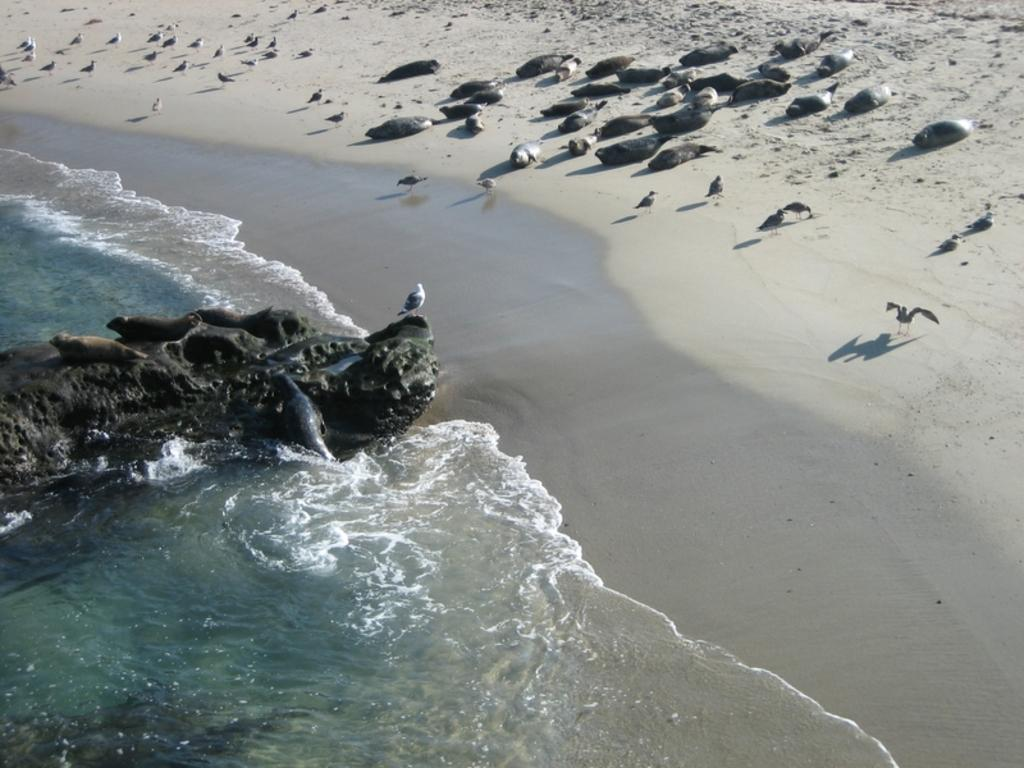What type of animals can be seen on the left side of the image? There are turtles and a bird on the left side of the image. What is the location of the rock in the image? The rock is partially in the water on the left side of the image. What type of animals can be seen on the right side of the image? There are turtles and birds on the right side of the image. What type of surface is visible on the right side of the image? The sand surface is on the right side of the image. What type of print can be seen on the turtles' shells in the image? There is no print visible on the turtles' shells in the image. Are the turtles and birds fighting with each other in the image? There is no indication of any fighting between the turtles and birds in the image. 